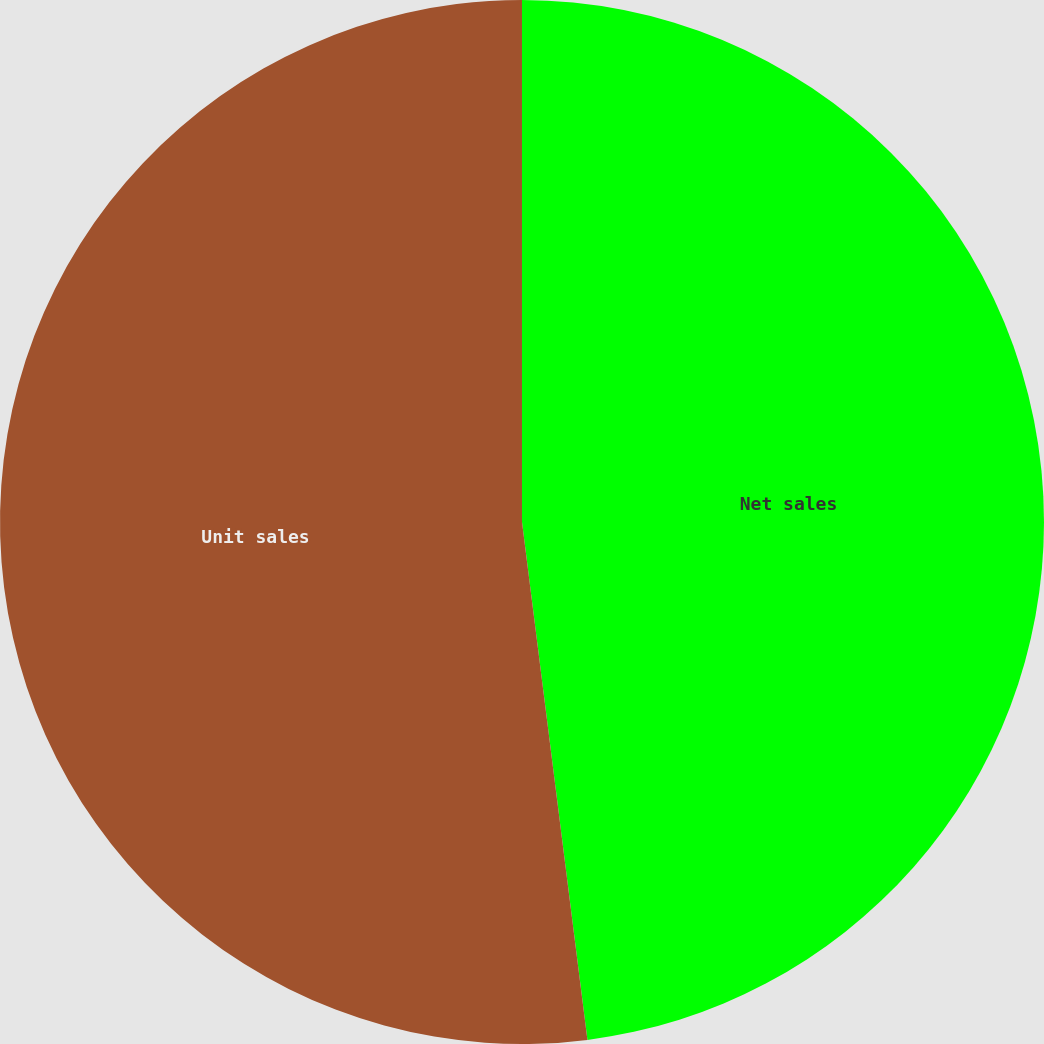<chart> <loc_0><loc_0><loc_500><loc_500><pie_chart><fcel>Net sales<fcel>Unit sales<nl><fcel>48.0%<fcel>52.0%<nl></chart> 